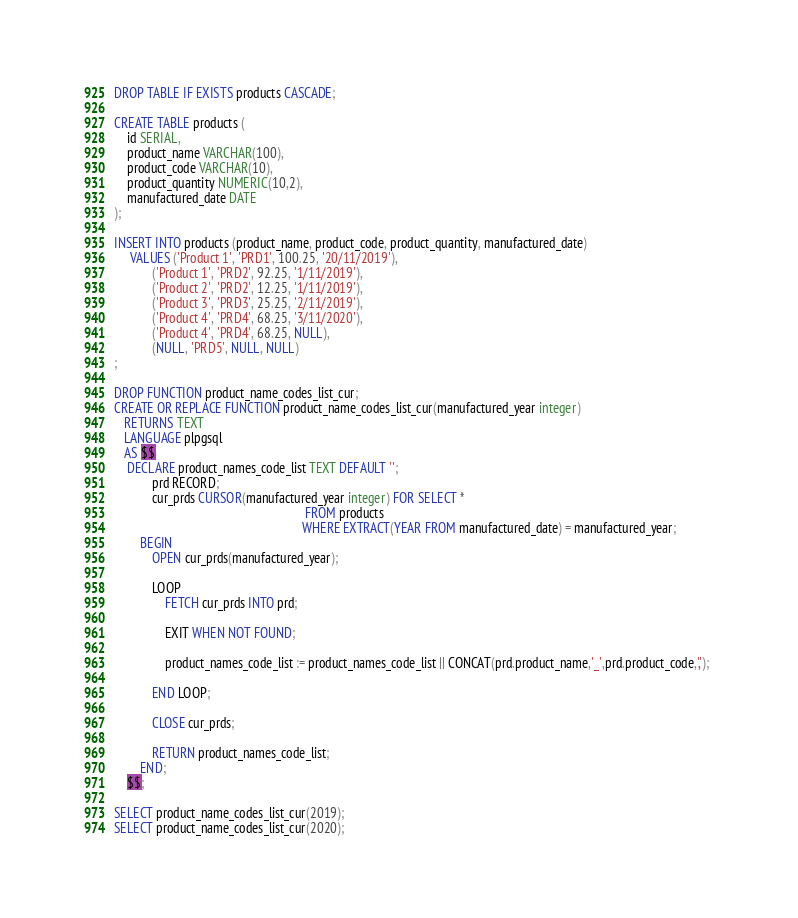Convert code to text. <code><loc_0><loc_0><loc_500><loc_500><_SQL_>DROP TABLE IF EXISTS products CASCADE;

CREATE TABLE products (
	id SERIAL,
	product_name VARCHAR(100),
	product_code VARCHAR(10),
	product_quantity NUMERIC(10,2),
	manufactured_date DATE
);

INSERT INTO products (product_name, product_code, product_quantity, manufactured_date)
 	 VALUES ('Product 1', 'PRD1', 100.25, '20/11/2019'),
 	 		('Product 1', 'PRD2', 92.25, '1/11/2019'),
 	 		('Product 2', 'PRD2', 12.25, '1/11/2019'),
 	 		('Product 3', 'PRD3', 25.25, '2/11/2019'),
 	 		('Product 4', 'PRD4', 68.25, '3/11/2020'),
 	 		('Product 4', 'PRD4', 68.25, NULL),
            (NULL, 'PRD5', NULL, NULL)
;

DROP FUNCTION product_name_codes_list_cur;
CREATE OR REPLACE FUNCTION product_name_codes_list_cur(manufactured_year integer) 
   RETURNS TEXT 
   LANGUAGE plpgsql
   AS $$
   	DECLARE product_names_code_list TEXT DEFAULT '';
   			prd RECORD;
   			cur_prds CURSOR(manufactured_year integer) FOR SELECT * 
    														FROM products 
     													   WHERE EXTRACT(YEAR FROM manufactured_date) = manufactured_year;   			
		BEGIN
			OPEN cur_prds(manufactured_year);
		
			LOOP 
				FETCH cur_prds INTO prd;
			
				EXIT WHEN NOT FOUND;
			
				product_names_code_list := product_names_code_list || CONCAT(prd.product_name,'_',prd.product_code,',');
			
			END LOOP;
		
			CLOSE cur_prds;
		
			RETURN product_names_code_list;
		END;
	$$;

SELECT product_name_codes_list_cur(2019);
SELECT product_name_codes_list_cur(2020);
</code> 